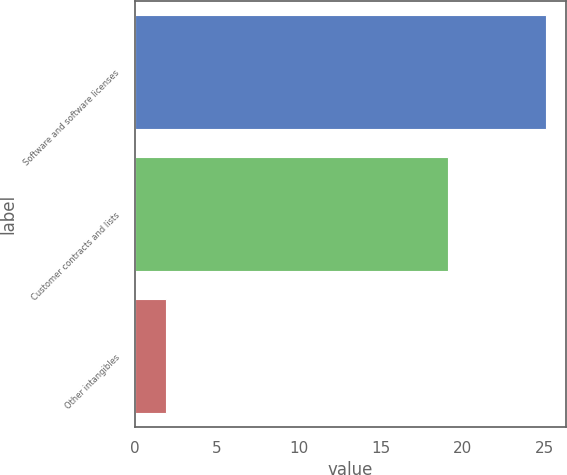<chart> <loc_0><loc_0><loc_500><loc_500><bar_chart><fcel>Software and software licenses<fcel>Customer contracts and lists<fcel>Other intangibles<nl><fcel>25.1<fcel>19.1<fcel>1.9<nl></chart> 